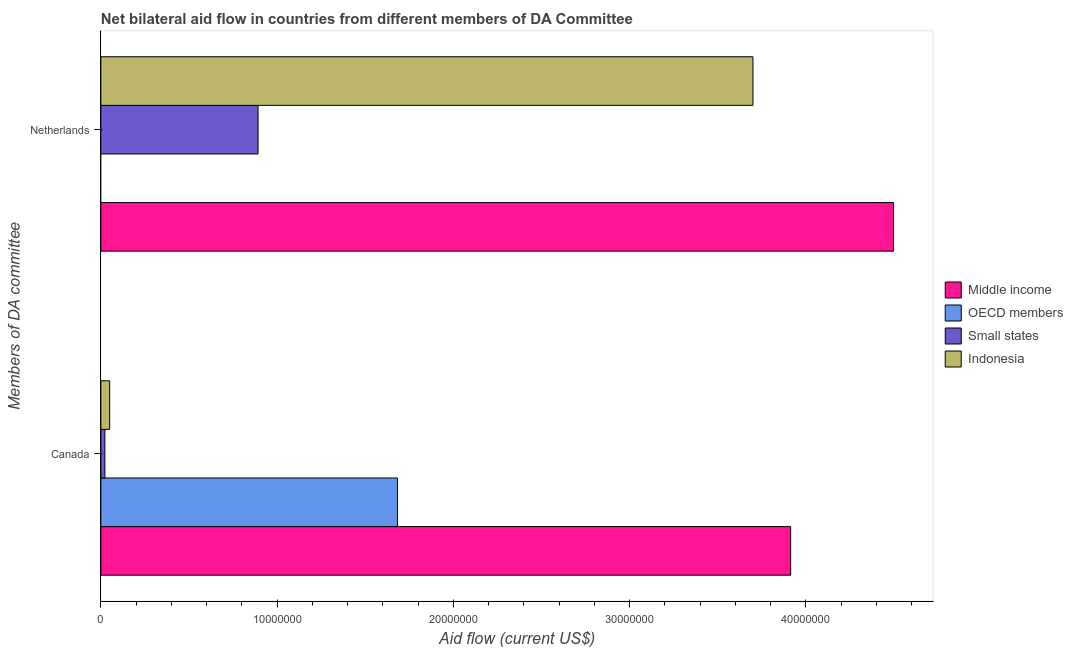How many different coloured bars are there?
Keep it short and to the point. 4. How many groups of bars are there?
Make the answer very short. 2. Are the number of bars per tick equal to the number of legend labels?
Give a very brief answer. No. How many bars are there on the 1st tick from the top?
Give a very brief answer. 3. What is the label of the 2nd group of bars from the top?
Make the answer very short. Canada. What is the amount of aid given by netherlands in Middle income?
Your answer should be compact. 4.50e+07. Across all countries, what is the maximum amount of aid given by netherlands?
Provide a succinct answer. 4.50e+07. Across all countries, what is the minimum amount of aid given by canada?
Provide a succinct answer. 2.30e+05. In which country was the amount of aid given by canada maximum?
Your response must be concise. Middle income. What is the total amount of aid given by canada in the graph?
Your answer should be very brief. 5.67e+07. What is the difference between the amount of aid given by netherlands in Small states and that in Middle income?
Your answer should be very brief. -3.61e+07. What is the difference between the amount of aid given by netherlands in Indonesia and the amount of aid given by canada in Middle income?
Your response must be concise. -2.14e+06. What is the average amount of aid given by netherlands per country?
Provide a short and direct response. 2.27e+07. What is the difference between the amount of aid given by canada and amount of aid given by netherlands in Small states?
Your answer should be compact. -8.69e+06. In how many countries, is the amount of aid given by canada greater than 18000000 US$?
Your answer should be compact. 1. What is the ratio of the amount of aid given by netherlands in Middle income to that in Small states?
Provide a short and direct response. 5.04. Is the amount of aid given by canada in OECD members less than that in Small states?
Keep it short and to the point. No. Are all the bars in the graph horizontal?
Your answer should be compact. Yes. How many countries are there in the graph?
Your response must be concise. 4. Does the graph contain grids?
Offer a very short reply. No. How are the legend labels stacked?
Provide a short and direct response. Vertical. What is the title of the graph?
Offer a terse response. Net bilateral aid flow in countries from different members of DA Committee. Does "Ghana" appear as one of the legend labels in the graph?
Keep it short and to the point. No. What is the label or title of the X-axis?
Provide a succinct answer. Aid flow (current US$). What is the label or title of the Y-axis?
Make the answer very short. Members of DA committee. What is the Aid flow (current US$) in Middle income in Canada?
Your response must be concise. 3.91e+07. What is the Aid flow (current US$) in OECD members in Canada?
Your answer should be compact. 1.68e+07. What is the Aid flow (current US$) of Small states in Canada?
Provide a short and direct response. 2.30e+05. What is the Aid flow (current US$) of Indonesia in Canada?
Keep it short and to the point. 5.00e+05. What is the Aid flow (current US$) of Middle income in Netherlands?
Ensure brevity in your answer.  4.50e+07. What is the Aid flow (current US$) of OECD members in Netherlands?
Provide a succinct answer. 0. What is the Aid flow (current US$) of Small states in Netherlands?
Offer a very short reply. 8.92e+06. What is the Aid flow (current US$) in Indonesia in Netherlands?
Make the answer very short. 3.70e+07. Across all Members of DA committee, what is the maximum Aid flow (current US$) of Middle income?
Your response must be concise. 4.50e+07. Across all Members of DA committee, what is the maximum Aid flow (current US$) of OECD members?
Your answer should be compact. 1.68e+07. Across all Members of DA committee, what is the maximum Aid flow (current US$) in Small states?
Give a very brief answer. 8.92e+06. Across all Members of DA committee, what is the maximum Aid flow (current US$) of Indonesia?
Provide a short and direct response. 3.70e+07. Across all Members of DA committee, what is the minimum Aid flow (current US$) of Middle income?
Provide a succinct answer. 3.91e+07. Across all Members of DA committee, what is the minimum Aid flow (current US$) in OECD members?
Your answer should be compact. 0. Across all Members of DA committee, what is the minimum Aid flow (current US$) in Small states?
Provide a succinct answer. 2.30e+05. Across all Members of DA committee, what is the minimum Aid flow (current US$) of Indonesia?
Offer a very short reply. 5.00e+05. What is the total Aid flow (current US$) of Middle income in the graph?
Keep it short and to the point. 8.41e+07. What is the total Aid flow (current US$) in OECD members in the graph?
Your response must be concise. 1.68e+07. What is the total Aid flow (current US$) of Small states in the graph?
Give a very brief answer. 9.15e+06. What is the total Aid flow (current US$) in Indonesia in the graph?
Provide a short and direct response. 3.75e+07. What is the difference between the Aid flow (current US$) of Middle income in Canada and that in Netherlands?
Your response must be concise. -5.84e+06. What is the difference between the Aid flow (current US$) of Small states in Canada and that in Netherlands?
Your response must be concise. -8.69e+06. What is the difference between the Aid flow (current US$) in Indonesia in Canada and that in Netherlands?
Offer a very short reply. -3.65e+07. What is the difference between the Aid flow (current US$) in Middle income in Canada and the Aid flow (current US$) in Small states in Netherlands?
Keep it short and to the point. 3.02e+07. What is the difference between the Aid flow (current US$) in Middle income in Canada and the Aid flow (current US$) in Indonesia in Netherlands?
Offer a terse response. 2.14e+06. What is the difference between the Aid flow (current US$) of OECD members in Canada and the Aid flow (current US$) of Small states in Netherlands?
Offer a terse response. 7.91e+06. What is the difference between the Aid flow (current US$) of OECD members in Canada and the Aid flow (current US$) of Indonesia in Netherlands?
Offer a terse response. -2.02e+07. What is the difference between the Aid flow (current US$) in Small states in Canada and the Aid flow (current US$) in Indonesia in Netherlands?
Your response must be concise. -3.68e+07. What is the average Aid flow (current US$) in Middle income per Members of DA committee?
Ensure brevity in your answer.  4.21e+07. What is the average Aid flow (current US$) in OECD members per Members of DA committee?
Offer a terse response. 8.42e+06. What is the average Aid flow (current US$) of Small states per Members of DA committee?
Provide a succinct answer. 4.58e+06. What is the average Aid flow (current US$) in Indonesia per Members of DA committee?
Offer a very short reply. 1.88e+07. What is the difference between the Aid flow (current US$) in Middle income and Aid flow (current US$) in OECD members in Canada?
Offer a very short reply. 2.23e+07. What is the difference between the Aid flow (current US$) in Middle income and Aid flow (current US$) in Small states in Canada?
Provide a short and direct response. 3.89e+07. What is the difference between the Aid flow (current US$) of Middle income and Aid flow (current US$) of Indonesia in Canada?
Give a very brief answer. 3.86e+07. What is the difference between the Aid flow (current US$) of OECD members and Aid flow (current US$) of Small states in Canada?
Give a very brief answer. 1.66e+07. What is the difference between the Aid flow (current US$) in OECD members and Aid flow (current US$) in Indonesia in Canada?
Provide a succinct answer. 1.63e+07. What is the difference between the Aid flow (current US$) of Middle income and Aid flow (current US$) of Small states in Netherlands?
Your answer should be very brief. 3.61e+07. What is the difference between the Aid flow (current US$) of Middle income and Aid flow (current US$) of Indonesia in Netherlands?
Provide a short and direct response. 7.98e+06. What is the difference between the Aid flow (current US$) in Small states and Aid flow (current US$) in Indonesia in Netherlands?
Give a very brief answer. -2.81e+07. What is the ratio of the Aid flow (current US$) of Middle income in Canada to that in Netherlands?
Provide a succinct answer. 0.87. What is the ratio of the Aid flow (current US$) in Small states in Canada to that in Netherlands?
Provide a succinct answer. 0.03. What is the ratio of the Aid flow (current US$) of Indonesia in Canada to that in Netherlands?
Your answer should be compact. 0.01. What is the difference between the highest and the second highest Aid flow (current US$) of Middle income?
Ensure brevity in your answer.  5.84e+06. What is the difference between the highest and the second highest Aid flow (current US$) in Small states?
Ensure brevity in your answer.  8.69e+06. What is the difference between the highest and the second highest Aid flow (current US$) in Indonesia?
Ensure brevity in your answer.  3.65e+07. What is the difference between the highest and the lowest Aid flow (current US$) in Middle income?
Provide a succinct answer. 5.84e+06. What is the difference between the highest and the lowest Aid flow (current US$) in OECD members?
Make the answer very short. 1.68e+07. What is the difference between the highest and the lowest Aid flow (current US$) of Small states?
Offer a terse response. 8.69e+06. What is the difference between the highest and the lowest Aid flow (current US$) in Indonesia?
Provide a succinct answer. 3.65e+07. 